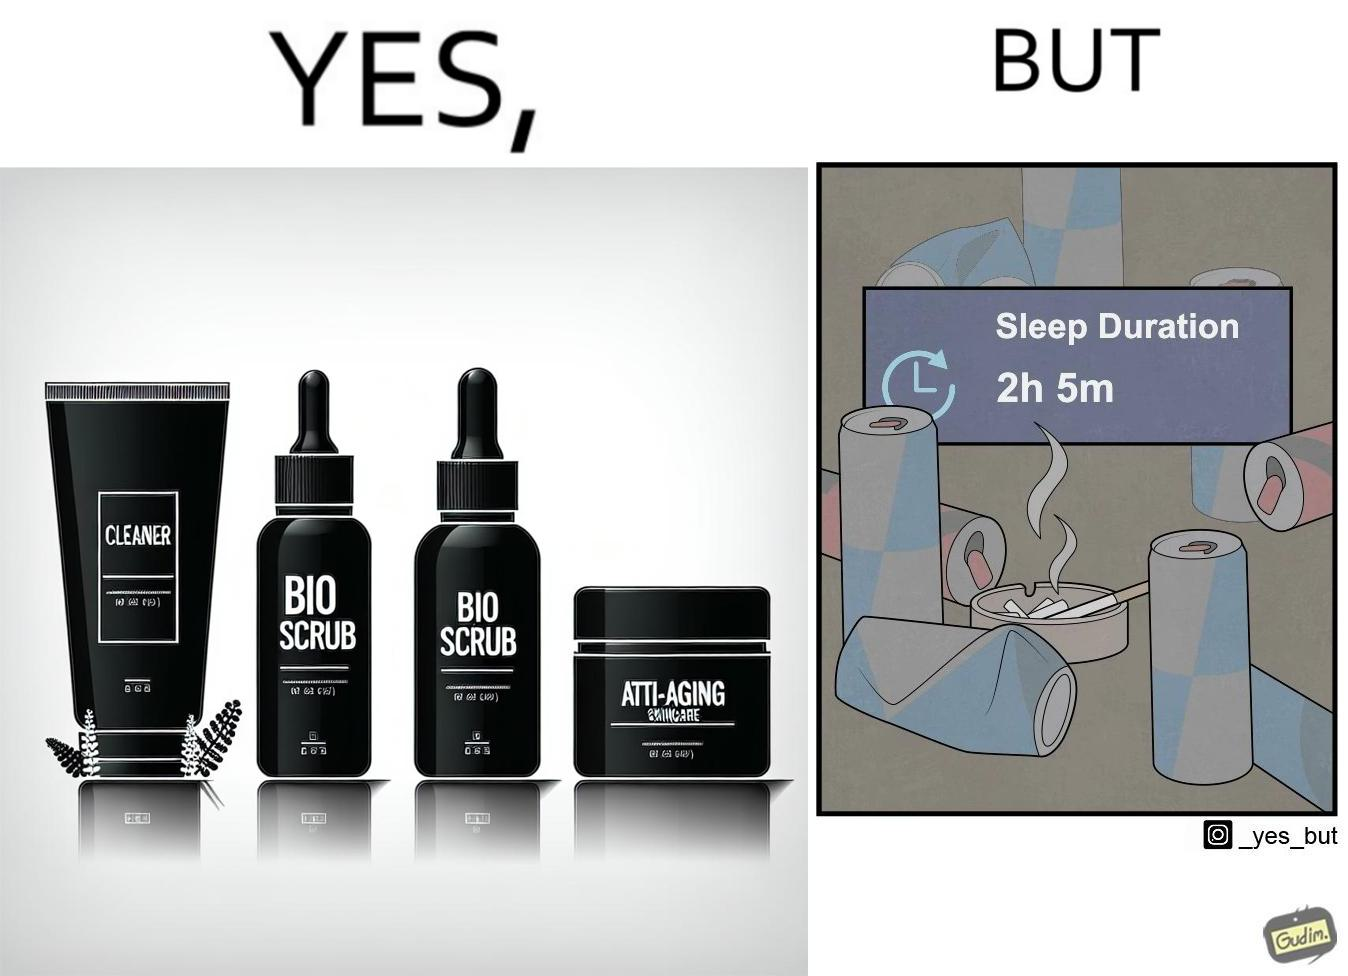What do you see in each half of this image? In the left part of the image: 4 Skincare products, arranged aesthetically. A tube labeled "Cleaner". A tube labeled "BIO SCRUB". A dropper bottle labeled "HYDRATING GEL". A jar called "ANTI-AGING SKINCARE". In the right part of the image: 9 cans of red bull, some standing upright, some crushed. Cans have blue and red colors. An ashtray with many cigarette butts in it and has smoke coming out. A banner that says "Sleep duration 2h 5min". 